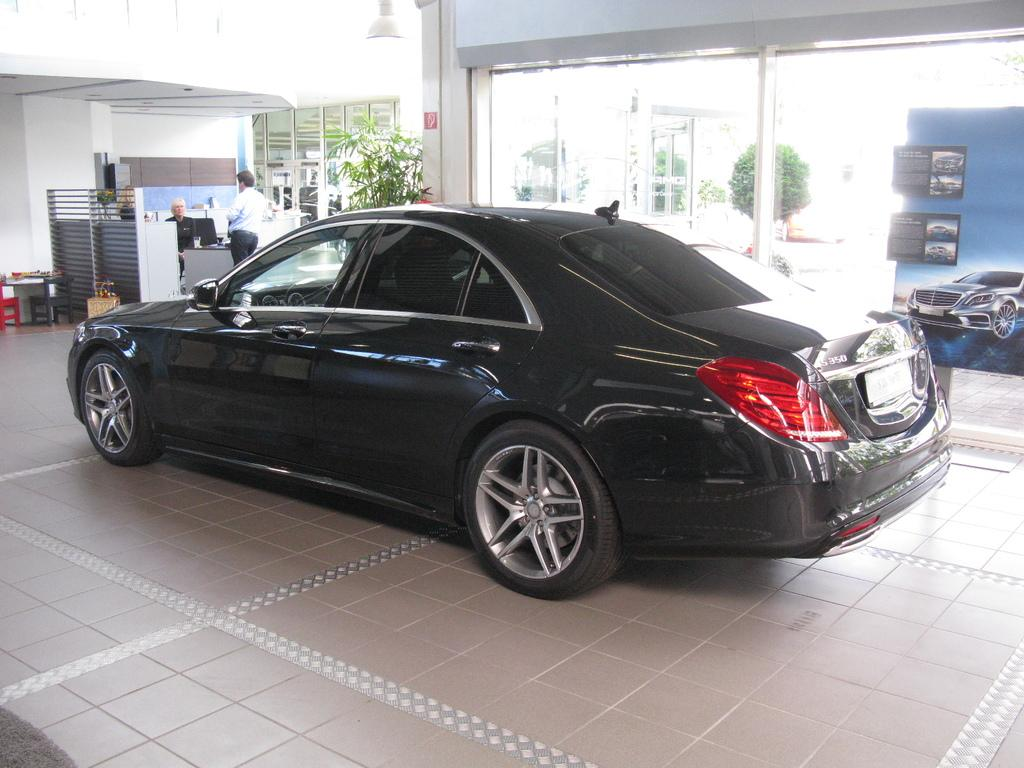What color is the car in the image? The car in the image is black. What can be seen in the background of the image? There are plants and a board visible in the background of the image. Are there any people in the image? Yes, there are two men visible in the background of the image. What type of leaf is being used by the chicken in the image? There is no chicken or leaf present in the image. 